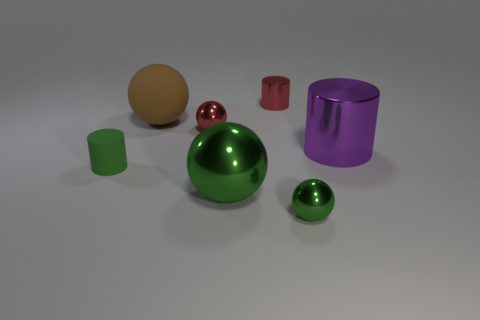There is a big metal thing that is to the left of the small red shiny object that is behind the red ball; what shape is it?
Ensure brevity in your answer.  Sphere. Are there more small yellow balls than green things?
Offer a very short reply. No. What number of tiny green objects are to the right of the red sphere and behind the large green thing?
Provide a succinct answer. 0. There is a metal sphere that is behind the purple shiny thing; what number of big green objects are on the left side of it?
Keep it short and to the point. 0. How many things are either spheres that are in front of the purple object or cylinders that are in front of the big brown thing?
Offer a terse response. 4. What material is the other green object that is the same shape as the large green object?
Ensure brevity in your answer.  Metal. What number of objects are either big objects that are left of the small green sphere or big brown spheres?
Offer a terse response. 2. The big purple object that is the same material as the big green sphere is what shape?
Offer a terse response. Cylinder. What number of big purple objects are the same shape as the small rubber thing?
Your response must be concise. 1. What is the big green thing made of?
Provide a succinct answer. Metal. 